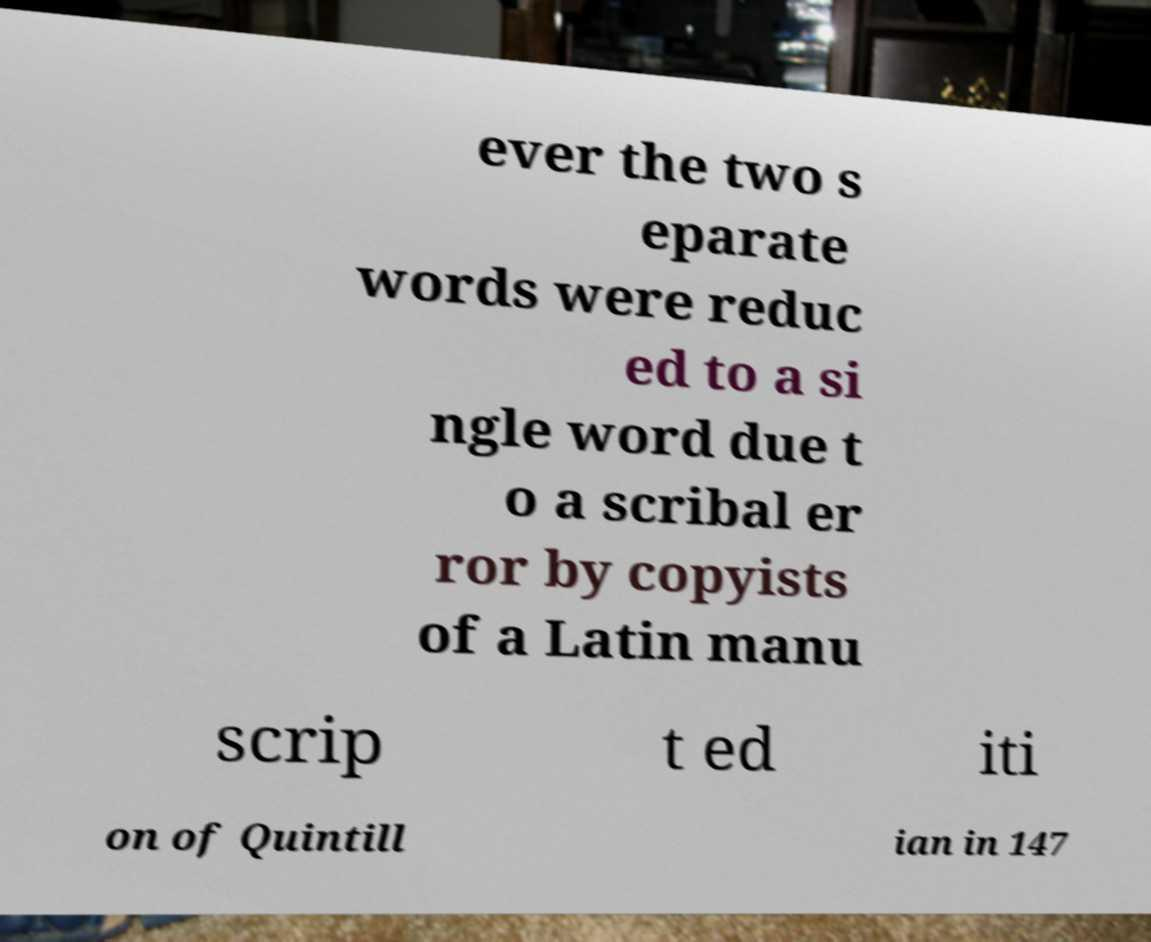Can you accurately transcribe the text from the provided image for me? ever the two s eparate words were reduc ed to a si ngle word due t o a scribal er ror by copyists of a Latin manu scrip t ed iti on of Quintill ian in 147 